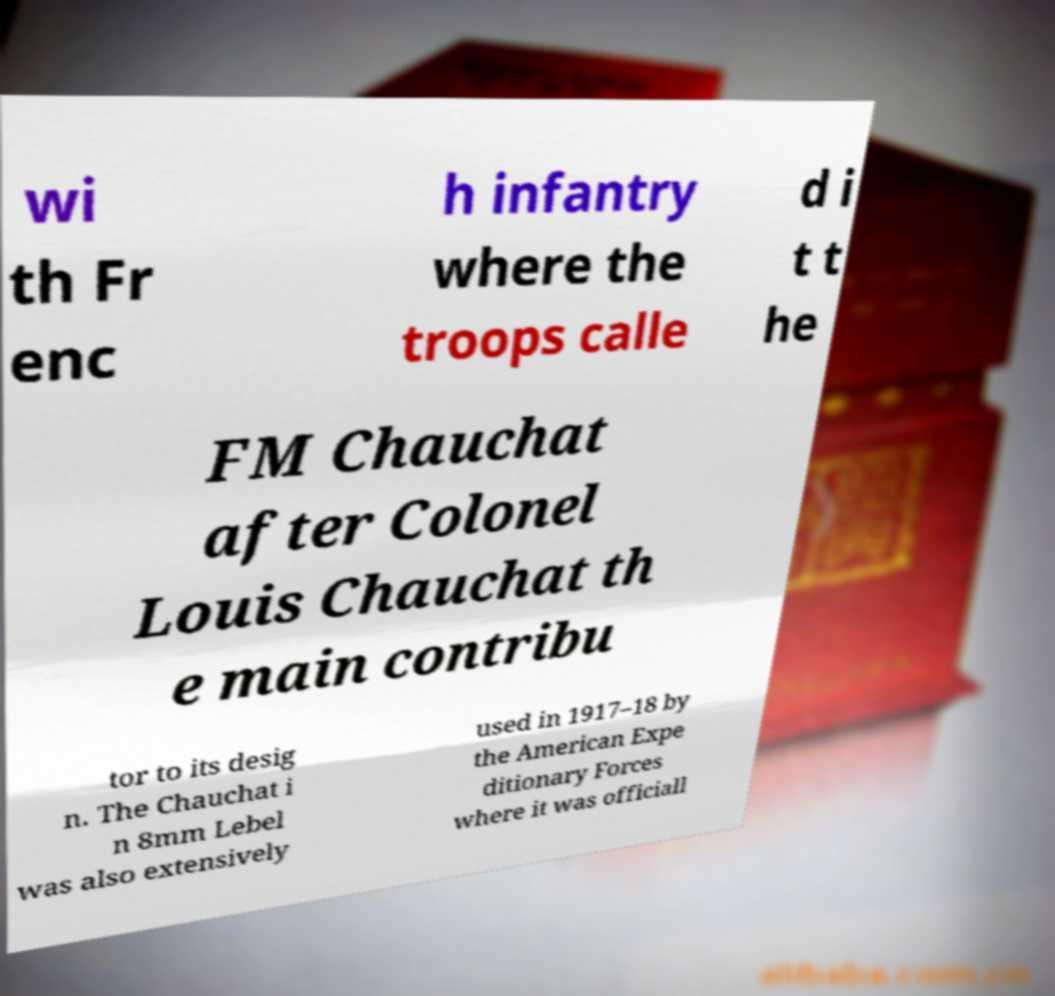Please read and relay the text visible in this image. What does it say? wi th Fr enc h infantry where the troops calle d i t t he FM Chauchat after Colonel Louis Chauchat th e main contribu tor to its desig n. The Chauchat i n 8mm Lebel was also extensively used in 1917–18 by the American Expe ditionary Forces where it was officiall 